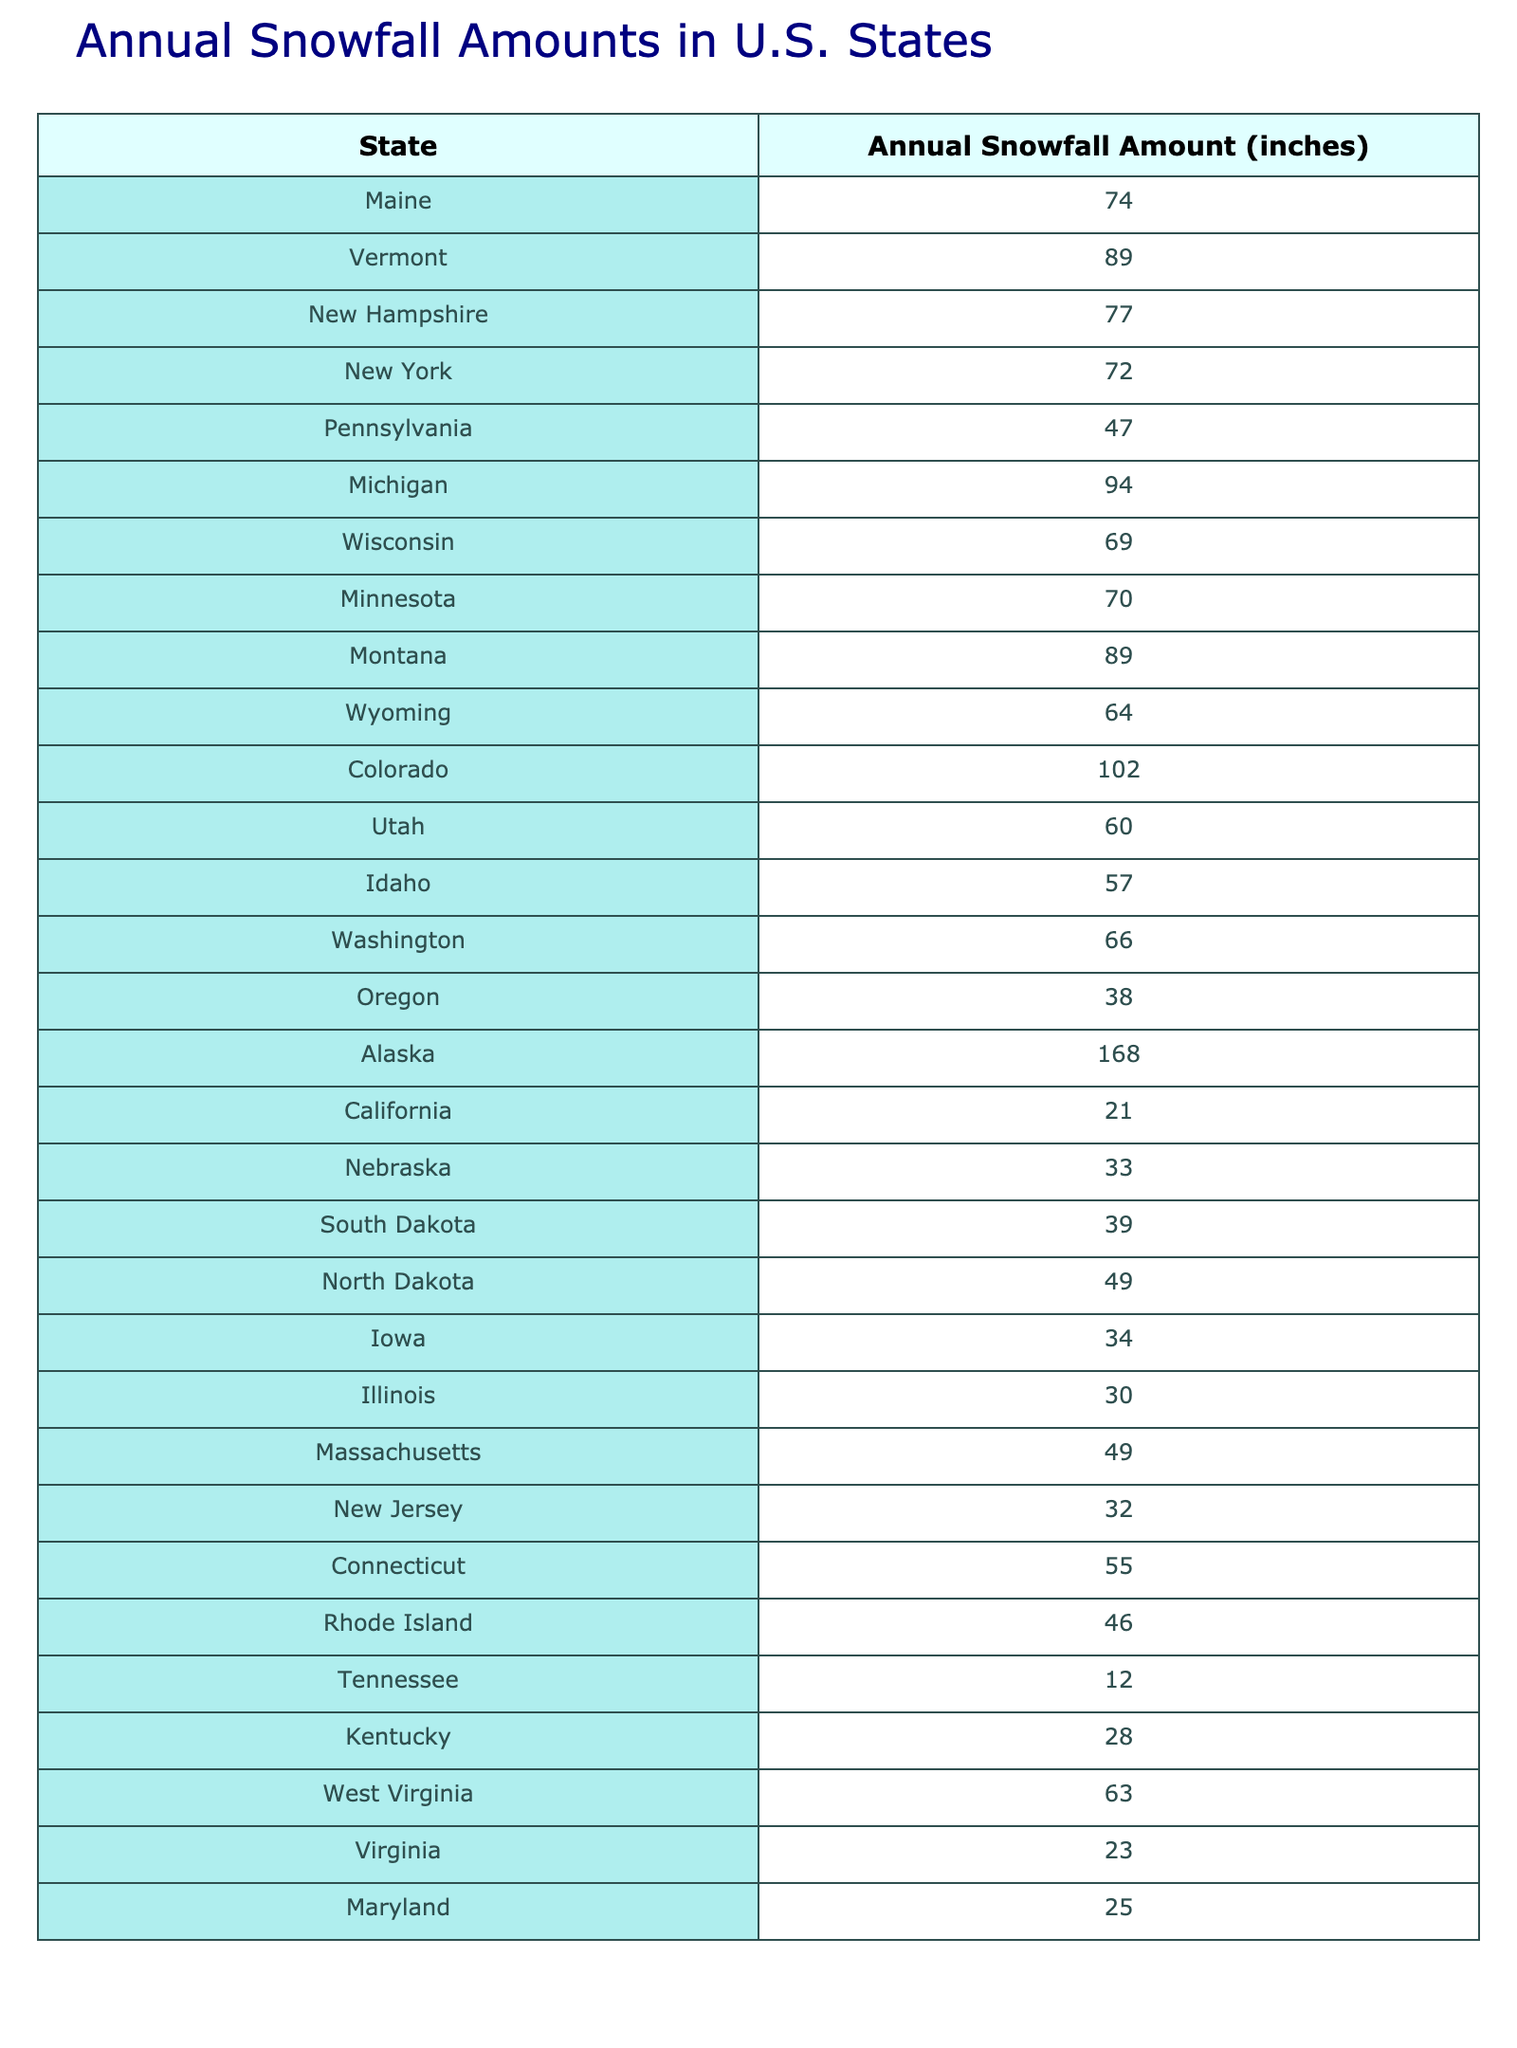What is the state with the highest annual snowfall amount? By examining the table, Alaska is listed with an annual snowfall amount of 168 inches, which is the highest value compared to all other states.
Answer: Alaska Which state has the lowest annual snowfall amount? The table indicates that California has the lowest annual snowfall amount at 21 inches.
Answer: California What is the average annual snowfall for the states listed in the table? First, sum all the snowfall amounts: 74 + 89 + 77 + 72 + 47 + 94 + 69 + 70 + 89 + 64 + 102 + 60 + 57 + 66 + 38 + 168 + 21 + 33 + 39 + 49 + 34 + 30 + 49 + 32 + 55 + 46 + 12 + 28 + 63 + 23 + 25 = 1037. There are 30 states listed, so the average is 1037/30 = 34.57, which rounds to approximately 34.57 inches.
Answer: 34.57 How many states have an annual snowfall amount greater than 60 inches? By reviewing the table, we can count the states with snowfall amounts greater than 60 inches: Maine, Vermont, New Hampshire, Michigan, Montana, Colorado, Alaska, and Wisconsin. This totals to 8 states.
Answer: 8 Is it true that New York has more snowfall than New Jersey? According to the table, New York has 72 inches of snowfall while New Jersey has only 32 inches. Thus, New York does indeed have more snowfall than New Jersey.
Answer: Yes Which two states have snowfall amounts that add up to exactly 120 inches? Looking through the pairs, Vermont (89 inches) and California (21 inches) sum to 110 inches, which is not 120. However, if we consider Vermont (89) and Tennessee (12), the total is still not 120. In fact, no two states from the list add up to precisely 120 inches as verified by checking all combinations.
Answer: No pairs found How much more snowfall does Michigan have compared to Illinois? Michigan has 94 inches of snowfall, while Illinois has 30 inches. The difference is 94 - 30 = 64 inches, meaning Michigan has 64 inches more snowfall compared to Illinois.
Answer: 64 inches What is the total annual snowfall for the states located in the Midwest (Illinois, Iowa, Indiana, etc.)? From the Midwest states available, we need to sum the amounts: Illinois (30) + Iowa (34) + Nebraska (33) + South Dakota (39) + North Dakota (49) = 30 + 34 + 33 + 39 + 49 = 185 inches total annual snowfall for the listed Midwest states.
Answer: 185 inches Are there any states with snowfall amounts in the 30s range? Yes, the states with snowfall amounts in the 30s are Illinois (30), Iowa (34), and Nebraska (33).
Answer: Yes Which state has a snowfall amount closest to the average snowfall of 34.57 inches? The values close to 34.57 are Nebraska (33 inches) and Iowa (34 inches), both very close to the average.
Answer: Nebraska and Iowa 